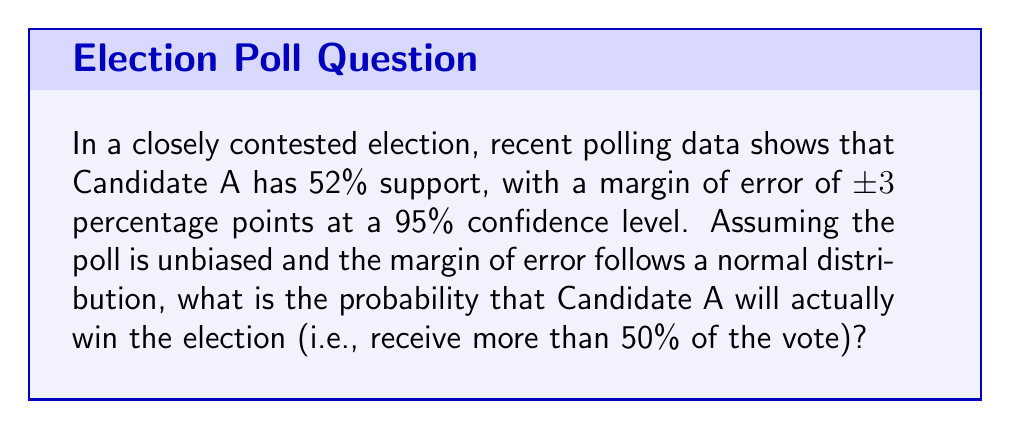Can you solve this math problem? To solve this problem, we'll follow these steps:

1) First, we need to understand what the margin of error means. In this case, we have a 95% confidence that the true percentage of support for Candidate A lies within the range of 52% ± 3%, or between 49% and 55%.

2) Given that this is a 95% confidence interval, we can infer that the standard error (SE) is half of the margin of error divided by 1.96 (the z-score for 95% confidence):

   $SE = \frac{3\%}{2 \times 1.96} \approx 0.7653\%$

3) Now, we want to find the probability that the true percentage is above 50%. We can use the z-score formula:

   $z = \frac{x - \mu}{\sigma}$

   Where $x$ is our threshold (50%), $\mu$ is our poll result (52%), and $\sigma$ is our standard error (0.7653%).

4) Plugging in these values:

   $z = \frac{50\% - 52\%}{0.7653\%} \approx -2.6134$

5) This negative z-score indicates that 50% is 2.6134 standard deviations below the mean of our distribution.

6) To find the probability of the true percentage being above 50%, we need to find the area to the right of this z-score on a standard normal distribution.

7) Using a z-table or calculator, we find that the area to the right of z = -2.6134 is approximately 0.9955.

8) Therefore, there is about a 99.55% chance that Candidate A's true support is above 50%, which is the probability of winning the election given this polling data.
Answer: 0.9955 or 99.55% 